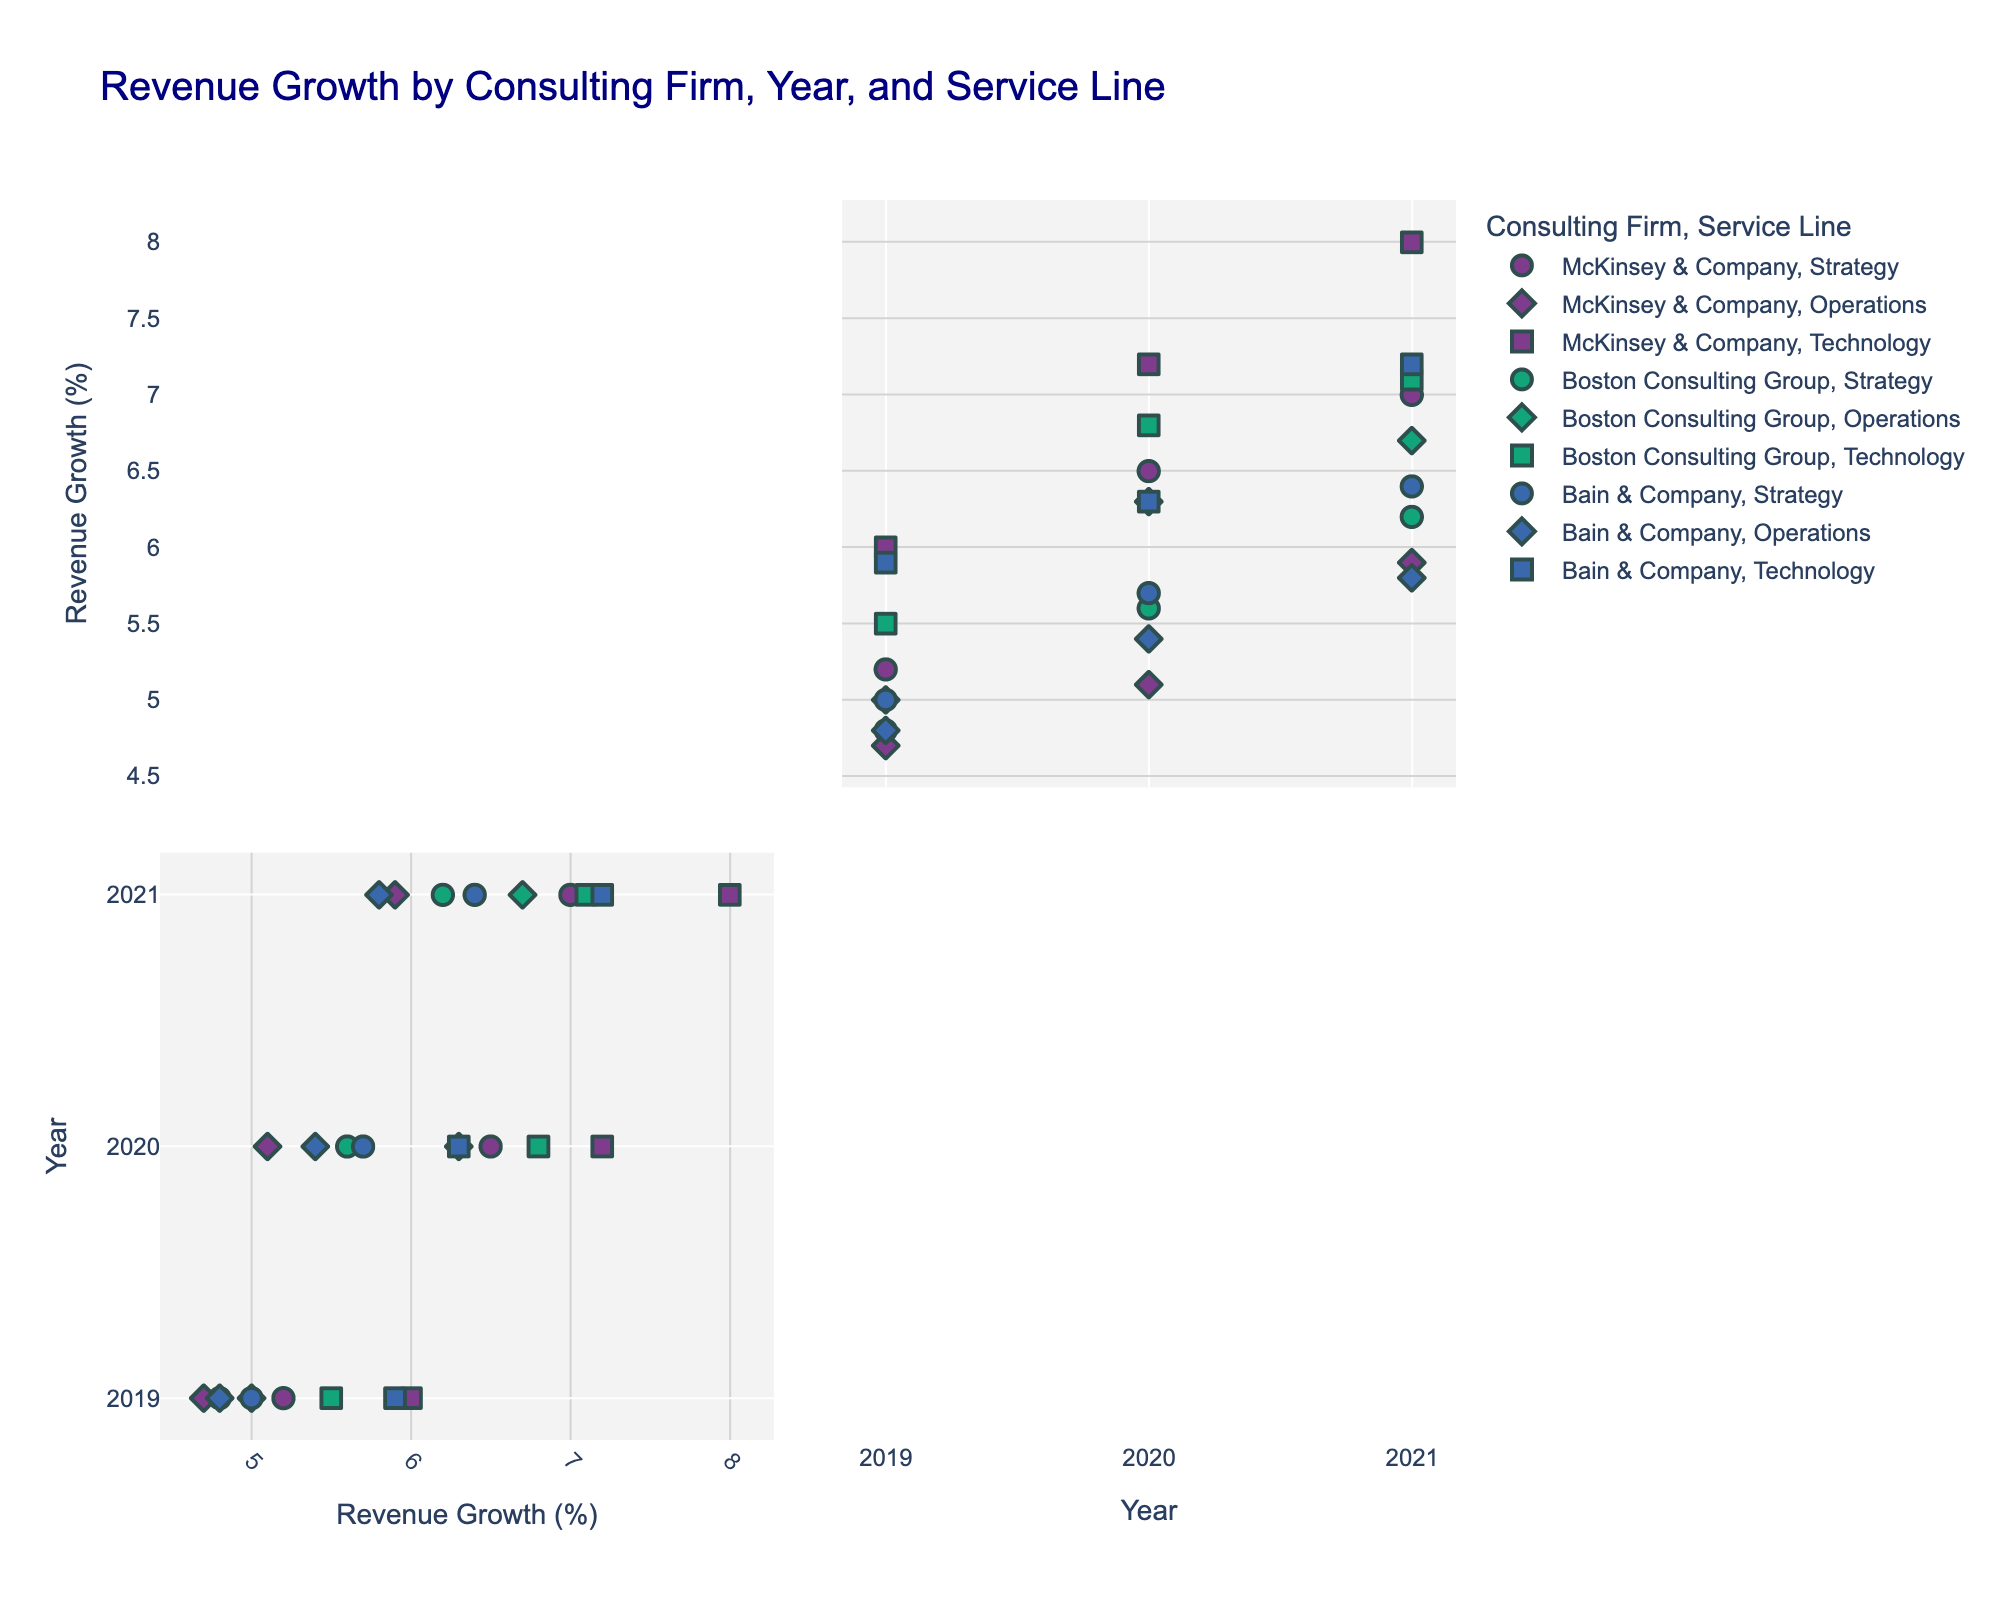Which consulting firm had the highest revenue growth in 2021? To answer this, identify the Consulting Firm with the highest data point for 2021 in the scatter plot matrix.
Answer: McKinsey & Company How did Boston Consulting Group's revenue growth in the technology service line change from 2019 to 2021? Locate the points associated with Boston Consulting Group and the Technology service line for the years 2019 to 2021 and look at the revenue growth values. Compare them.
Answer: It increased from 5.5% to 7.1% Which service line of Bain & Company had the highest revenue growth in 2020? Find the points for Bain & Company in 2020 and compare the revenue growth values of the different service lines.
Answer: Technology On average, which consulting firm showed the highest revenue growth across all years and service lines? Calculate the average revenue growth for each consulting firm by summing their revenue growth percentages and dividing by the number of data points. Compare the averages.
Answer: McKinsey & Company Does the Operations service line have consistent revenue growth across all consulting firms for 2021? Review the revenue growth data points for all consulting firms within the Operations service line for 2021 and compare their values to determine consistency.
Answer: No, it varies Which consulting firm experienced the highest increase in revenue growth in the Strategy service line from 2020 to 2021? Identify the Strategy service line points for 2020 and 2021 for all firms, then find the firm with the highest difference in revenue growth between these years.
Answer: McKinsey & Company Are there any consulting firms that show a decrease in revenue growth in any service line from 2019 to 2021? Examine the revenue growth for each consulting firm's service lines from 2019 to 2021 to see if there are any declines.
Answer: No In 2019, which consulting firm had the lowest revenue growth in the Operations service line? Find and compare the data points related to the Operations service line for all consulting firms in 2019. Identify the firm with the lowest revenue growth.
Answer: Bain & Company How does the revenue growth of the Strategy service line compare across different firms in 2020? Compare the revenue growth values for the Strategy service line for each consulting firm in 2020.
Answer: McKinsey & Company: 6.5%, Boston Consulting Group: 5.6%, Bain & Company: 5.7% 